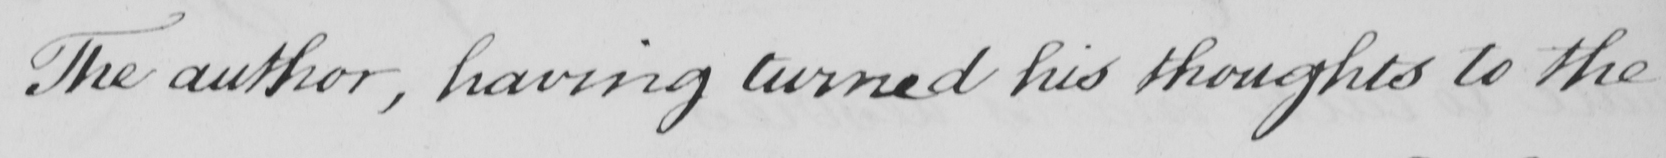Please transcribe the handwritten text in this image. The author , having turned his thoughts to the 